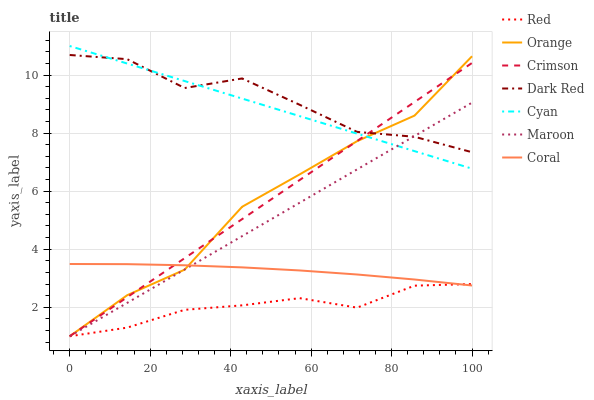Does Red have the minimum area under the curve?
Answer yes or no. Yes. Does Dark Red have the maximum area under the curve?
Answer yes or no. Yes. Does Coral have the minimum area under the curve?
Answer yes or no. No. Does Coral have the maximum area under the curve?
Answer yes or no. No. Is Cyan the smoothest?
Answer yes or no. Yes. Is Dark Red the roughest?
Answer yes or no. Yes. Is Coral the smoothest?
Answer yes or no. No. Is Coral the roughest?
Answer yes or no. No. Does Coral have the lowest value?
Answer yes or no. No. Does Cyan have the highest value?
Answer yes or no. Yes. Does Coral have the highest value?
Answer yes or no. No. Is Red less than Dark Red?
Answer yes or no. Yes. Is Dark Red greater than Coral?
Answer yes or no. Yes. Does Red intersect Dark Red?
Answer yes or no. No. 